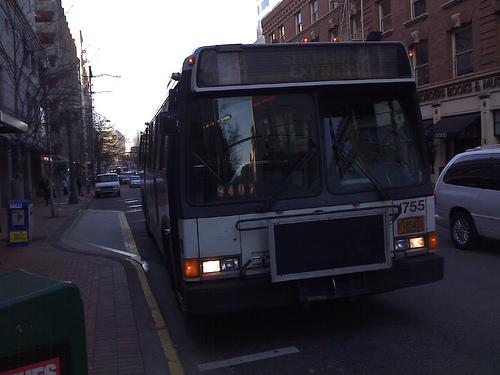What is the bus next to?

Choices:
A) palm tree
B) curb
C) cat
D) baby curb 